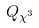Convert formula to latex. <formula><loc_0><loc_0><loc_500><loc_500>Q _ { \chi ^ { 3 } }</formula> 